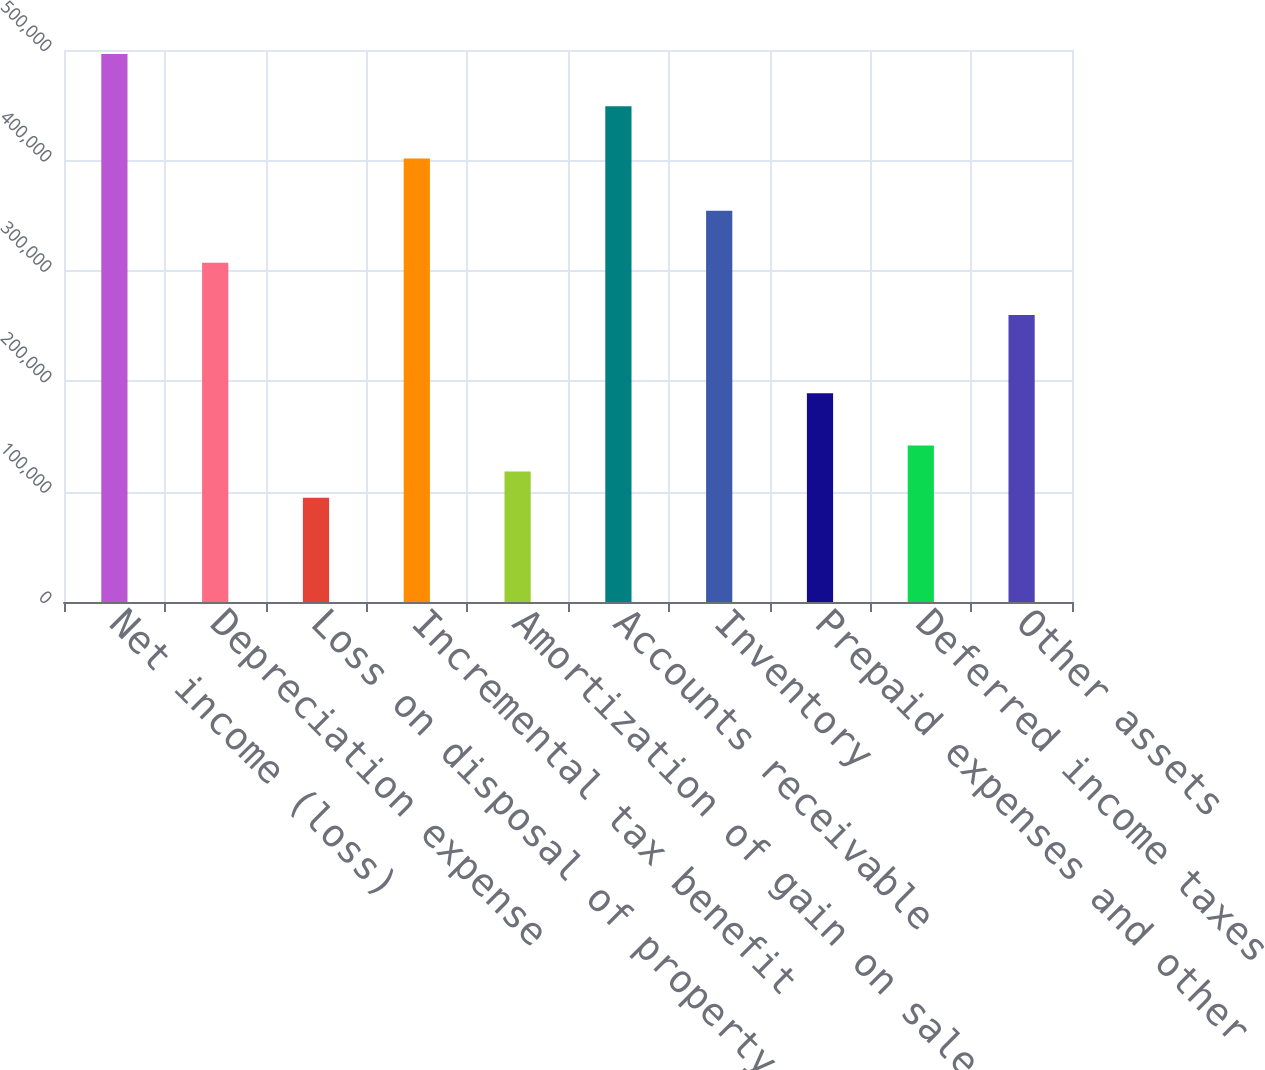<chart> <loc_0><loc_0><loc_500><loc_500><bar_chart><fcel>Net income (loss)<fcel>Depreciation expense<fcel>Loss on disposal of property<fcel>Incremental tax benefit<fcel>Amortization of gain on sale<fcel>Accounts receivable<fcel>Inventory<fcel>Prepaid expenses and other<fcel>Deferred income taxes<fcel>Other assets<nl><fcel>496292<fcel>307229<fcel>94534.2<fcel>401761<fcel>118167<fcel>449026<fcel>354495<fcel>189065<fcel>141800<fcel>259964<nl></chart> 